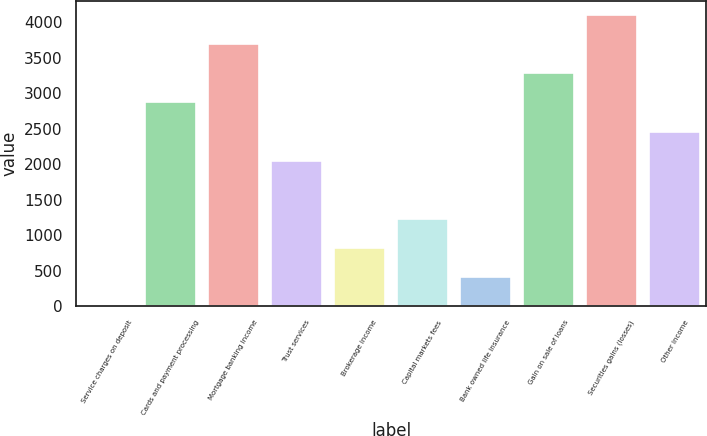<chart> <loc_0><loc_0><loc_500><loc_500><bar_chart><fcel>Service charges on deposit<fcel>Cards and payment processing<fcel>Mortgage banking income<fcel>Trust services<fcel>Brokerage income<fcel>Capital markets fees<fcel>Bank owned life insurance<fcel>Gain on sale of loans<fcel>Securities gains (losses)<fcel>Other income<nl><fcel>1<fcel>2870.3<fcel>3690.1<fcel>2050.5<fcel>820.8<fcel>1230.7<fcel>410.9<fcel>3280.2<fcel>4100<fcel>2460.4<nl></chart> 